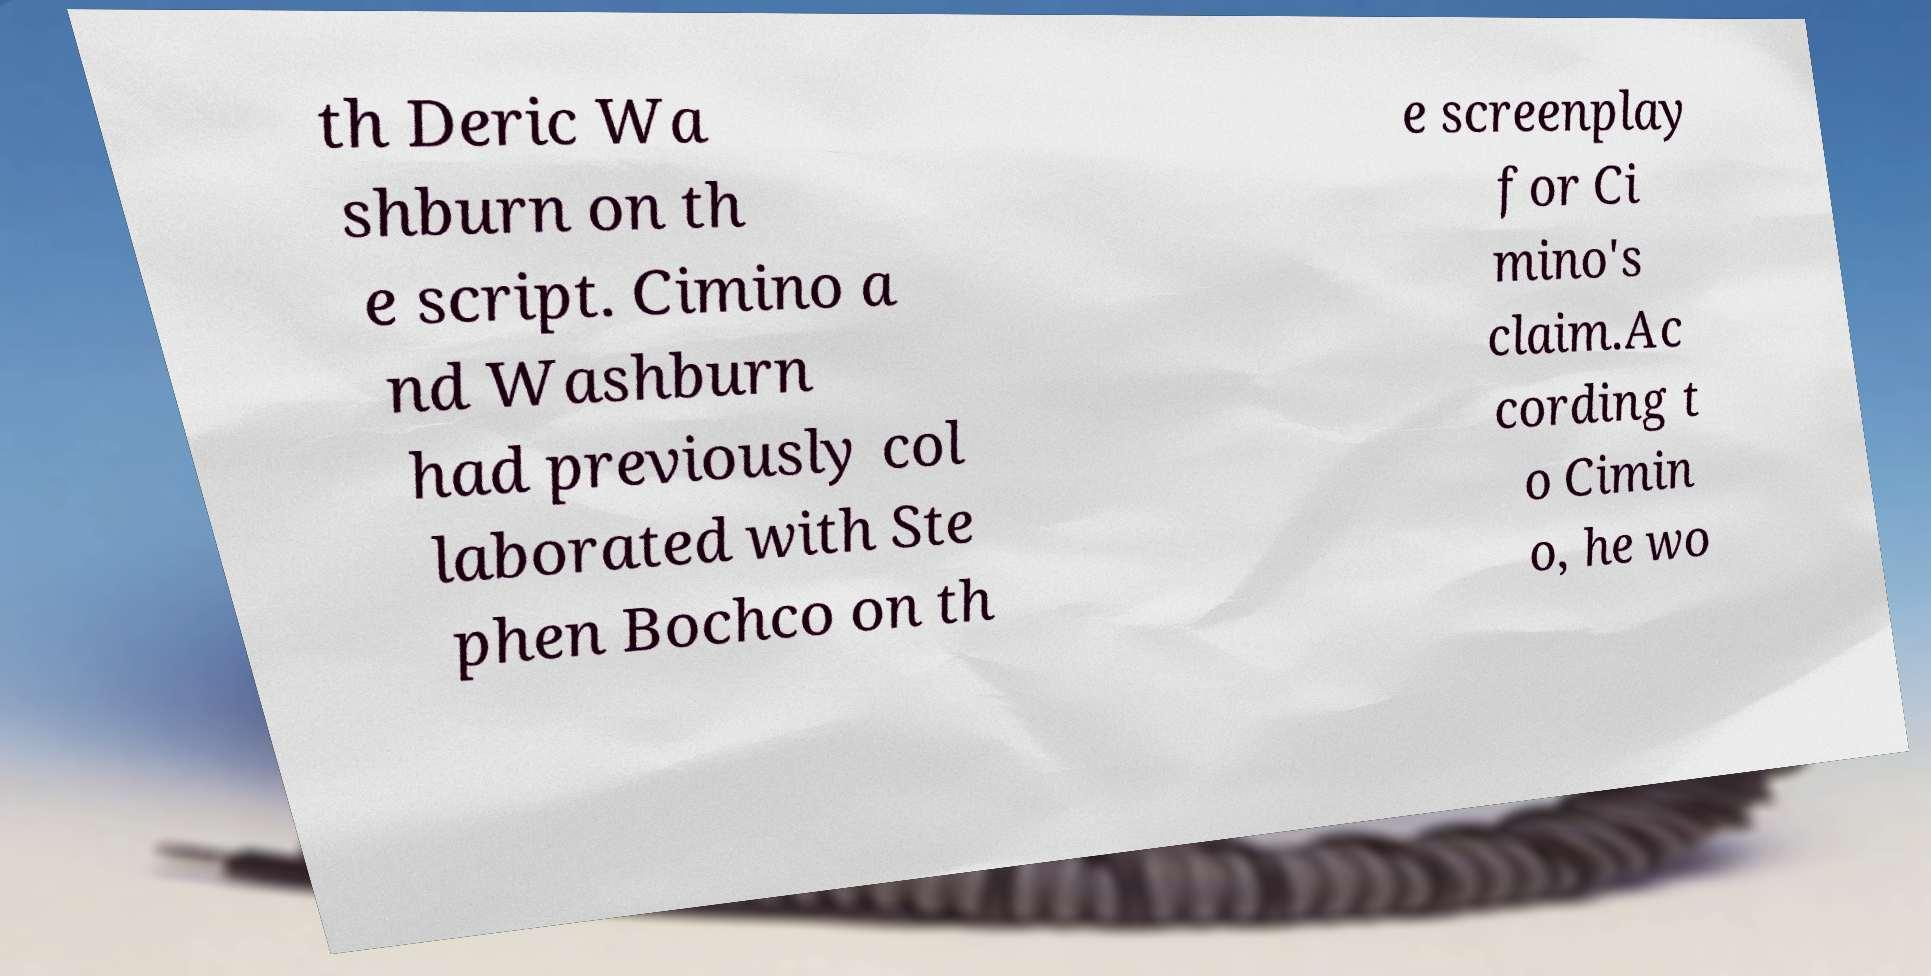Could you extract and type out the text from this image? th Deric Wa shburn on th e script. Cimino a nd Washburn had previously col laborated with Ste phen Bochco on th e screenplay for Ci mino's claim.Ac cording t o Cimin o, he wo 